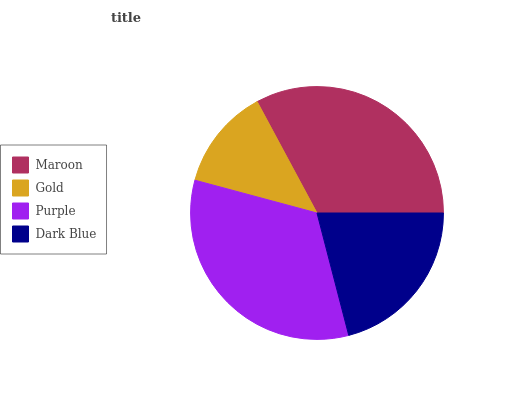Is Gold the minimum?
Answer yes or no. Yes. Is Purple the maximum?
Answer yes or no. Yes. Is Purple the minimum?
Answer yes or no. No. Is Gold the maximum?
Answer yes or no. No. Is Purple greater than Gold?
Answer yes or no. Yes. Is Gold less than Purple?
Answer yes or no. Yes. Is Gold greater than Purple?
Answer yes or no. No. Is Purple less than Gold?
Answer yes or no. No. Is Maroon the high median?
Answer yes or no. Yes. Is Dark Blue the low median?
Answer yes or no. Yes. Is Purple the high median?
Answer yes or no. No. Is Gold the low median?
Answer yes or no. No. 